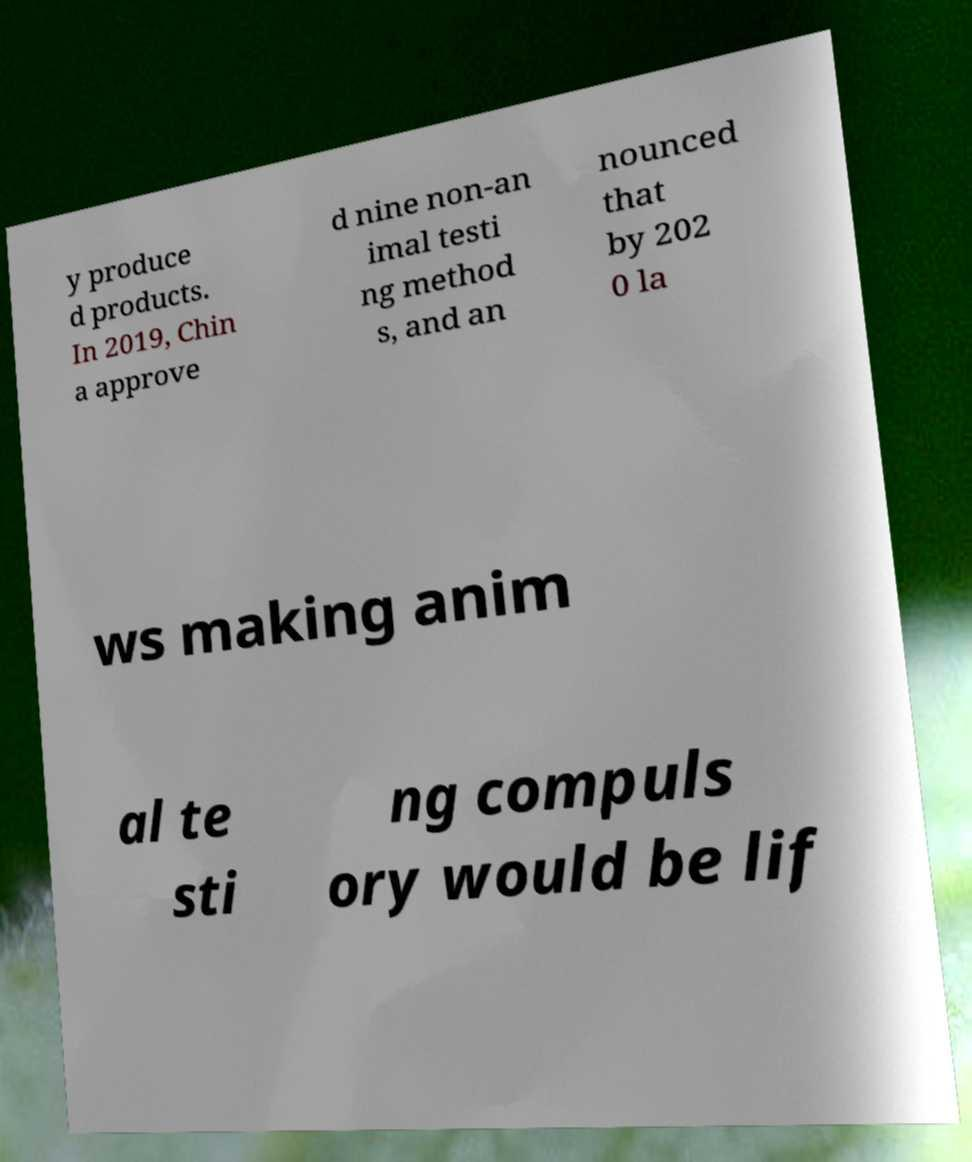Can you read and provide the text displayed in the image?This photo seems to have some interesting text. Can you extract and type it out for me? y produce d products. In 2019, Chin a approve d nine non-an imal testi ng method s, and an nounced that by 202 0 la ws making anim al te sti ng compuls ory would be lif 